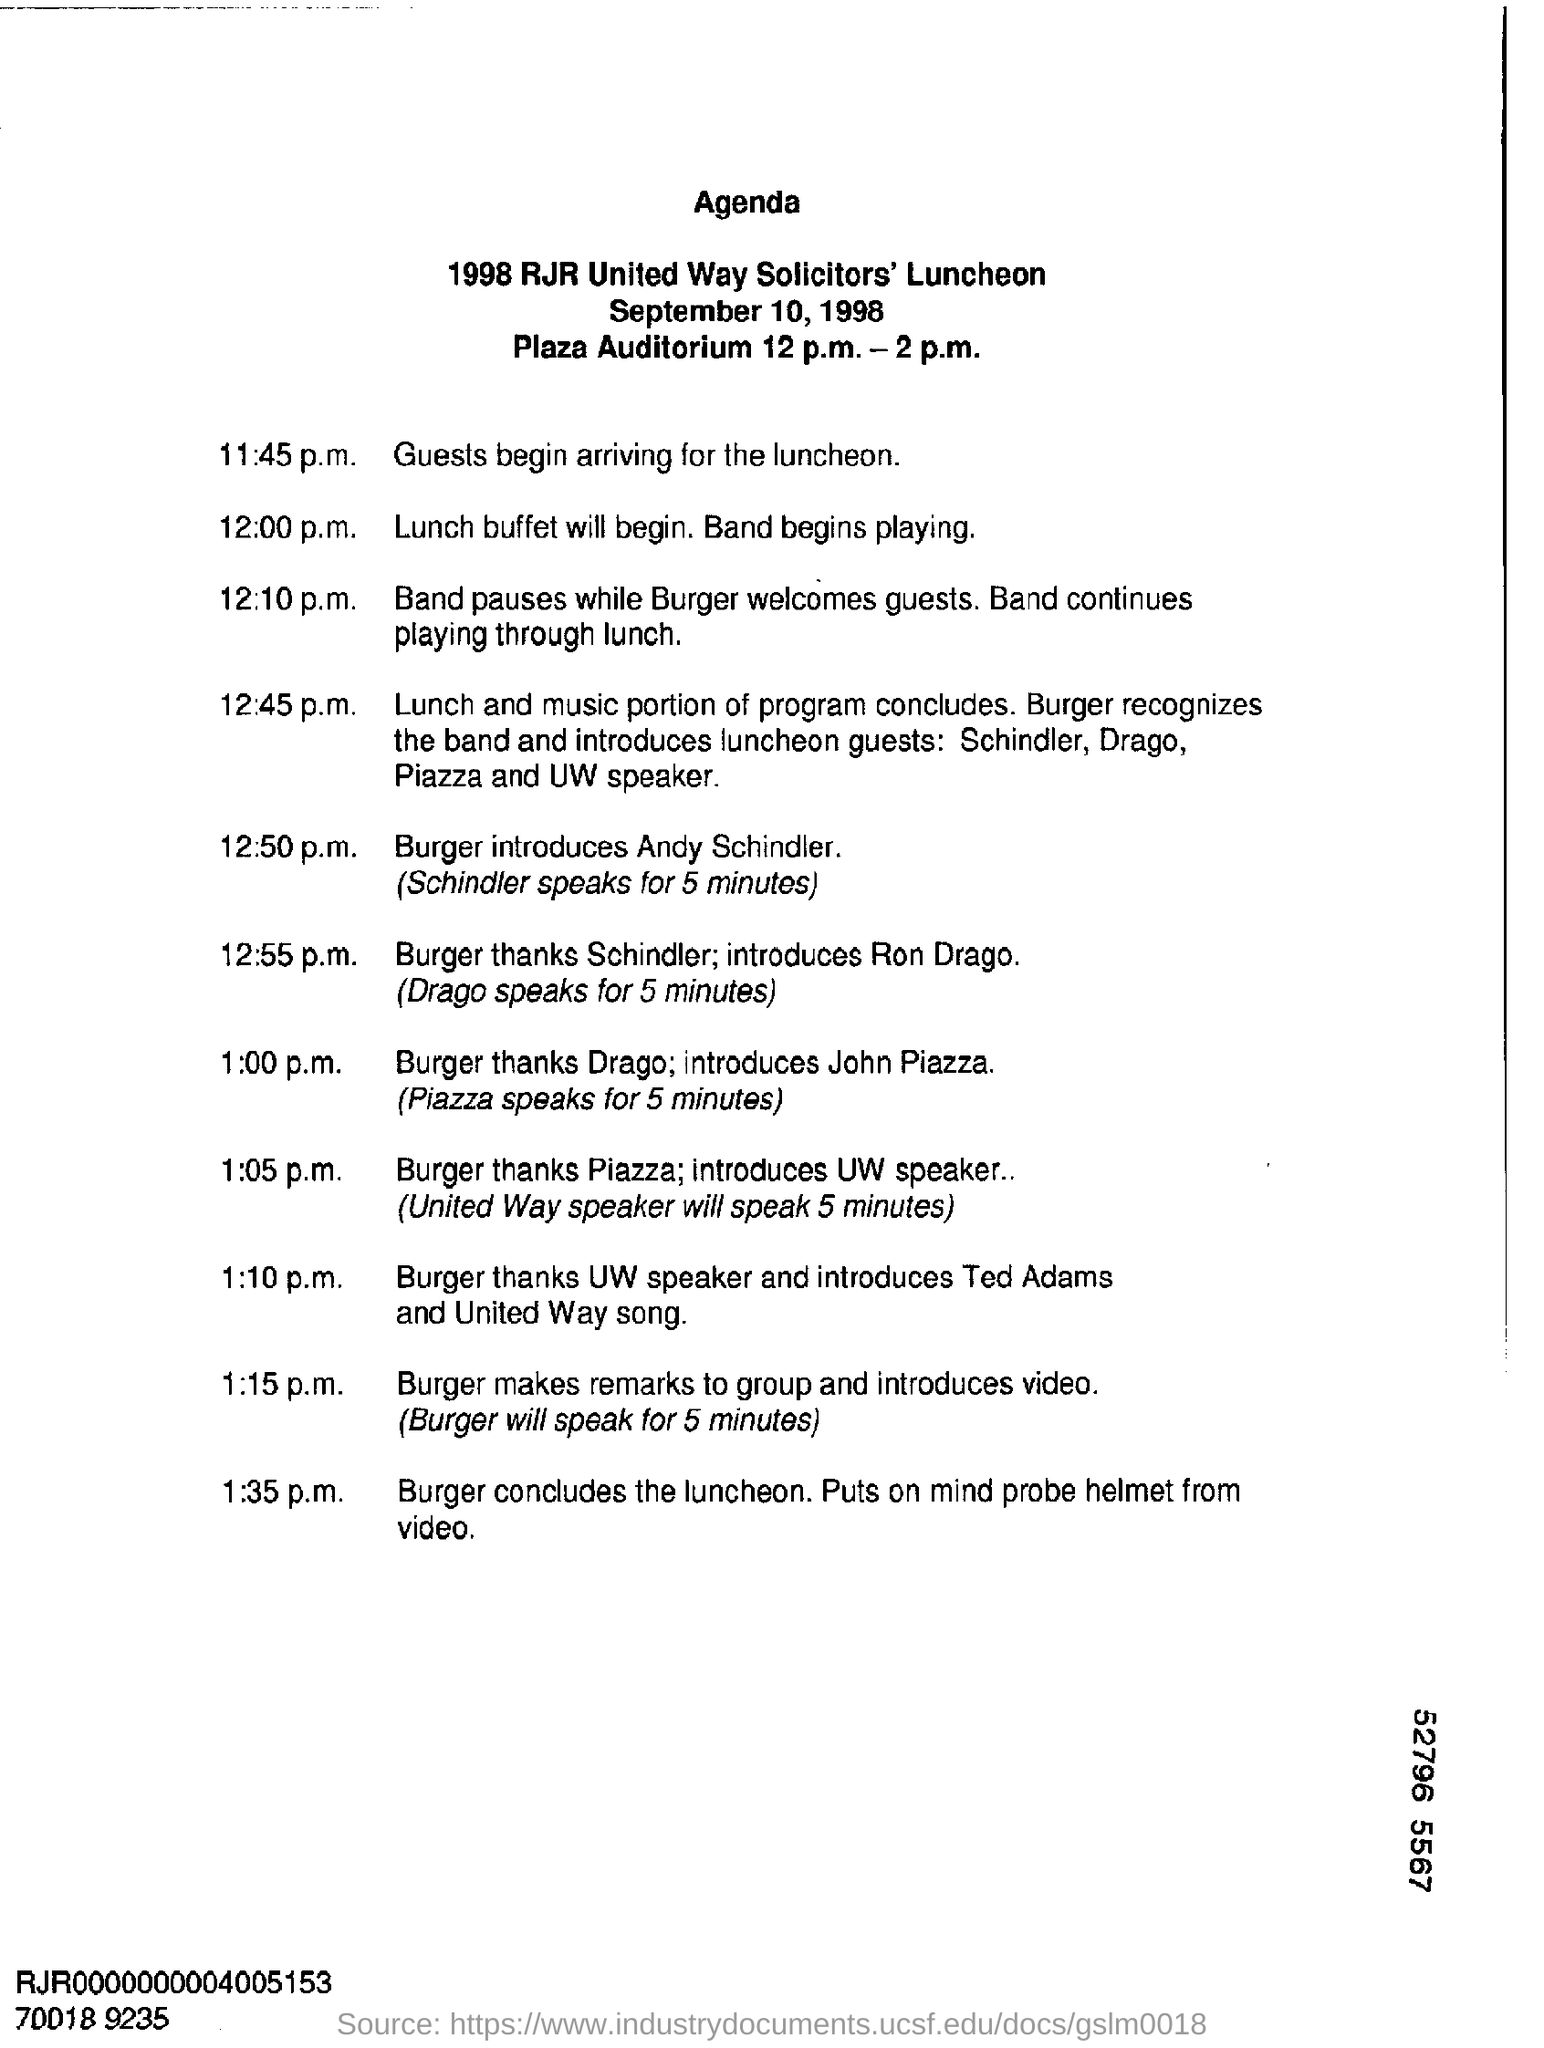Give some essential details in this illustration. Burger will introduce Andy Schindler at 12:50 p.m. The 1998 RJR United Way Solicitor's Luncheon will be held on September 10, 1998. 